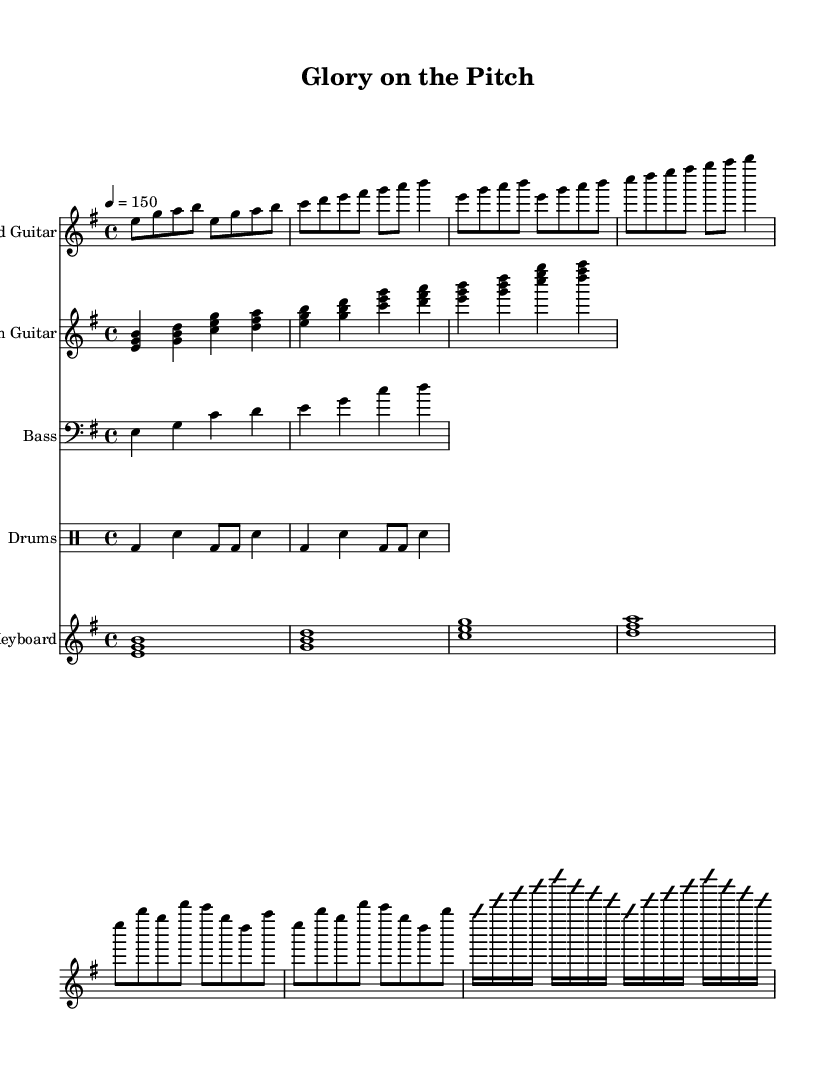What is the key signature of this music? The key signature is E minor, which has one sharp (F#). This can be determined by looking at the key signature indicated at the start of the sheet music, labeled with a "♯" sign beside the note F.
Answer: E minor What is the time signature of this music? The time signature is 4/4, which can be found at the beginning of the sheet music. It denotes that there are four beats in a measure and that the quarter note gets one beat.
Answer: 4/4 What is the tempo marking given in this music? The tempo marking is 150 BPM (beats per minute), as indicated in the sheet titled "tempo 4 = 150." This indicates the speed at which the piece should be played.
Answer: 150 What is the form of this metal song? The song structure includes intro, verse, chorus, and solo sections, as indicated by the distinct sections in the music. The presence of these sections is typical for songs in the power metal genre.
Answer: Verse-Chorus form How many measures are in the chorus section? The chorus section consists of 8 measures. By counting the number of measures from the start of the chorus to its end, we can confirm that there are 8 distinct measures in this part of the piece.
Answer: 8 What type of guitar is featured prominently in this piece? The lead and rhythm guitar are both prominent in this piece; however, the lead guitar features solo improvisation, making it a highlight. The distinct notations for each guitar part show their contributions to the overall sound.
Answer: Lead Guitar What kind of drum pattern is present in this music? The drum part displays a basic rock beat, which is characterized by the placement of bass and snare drums that maintain a steady rhythm throughout. The drum notation shows a repeated pattern typical in metal compositions.
Answer: Basic rock beat 